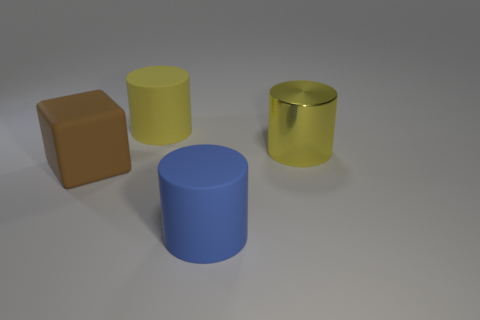What number of rubber things have the same color as the big block?
Give a very brief answer. 0. What number of big things are either yellow things or brown blocks?
Offer a very short reply. 3. Are there any other big shiny things that have the same shape as the shiny thing?
Your answer should be very brief. No. Do the brown matte thing and the large metallic thing have the same shape?
Keep it short and to the point. No. What color is the large matte cylinder that is in front of the big cylinder behind the metal cylinder?
Keep it short and to the point. Blue. There is a matte cube that is the same size as the yellow metal object; what is its color?
Ensure brevity in your answer.  Brown. What number of metal things are either tiny yellow blocks or blocks?
Make the answer very short. 0. What number of large blue rubber things are behind the big yellow cylinder right of the blue matte object?
Provide a succinct answer. 0. What is the size of the object that is the same color as the metallic cylinder?
Your answer should be very brief. Large. What number of things are either big objects or large matte things that are behind the big blue rubber cylinder?
Your response must be concise. 4. 